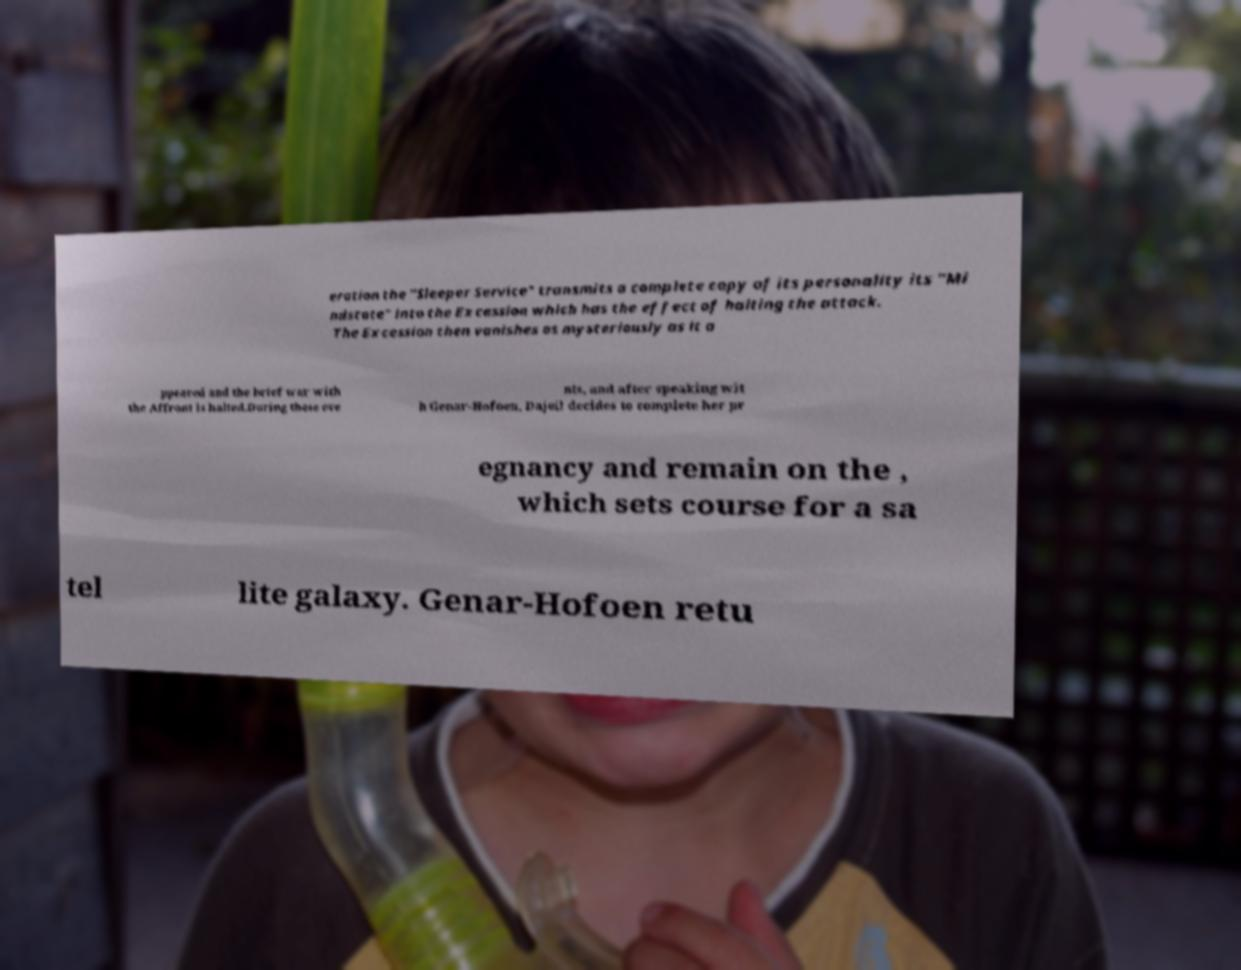What messages or text are displayed in this image? I need them in a readable, typed format. eration the "Sleeper Service" transmits a complete copy of its personality its "Mi ndstate" into the Excession which has the effect of halting the attack. The Excession then vanishes as mysteriously as it a ppeared and the brief war with the Affront is halted.During these eve nts, and after speaking wit h Genar-Hofoen, Dajeil decides to complete her pr egnancy and remain on the , which sets course for a sa tel lite galaxy. Genar-Hofoen retu 